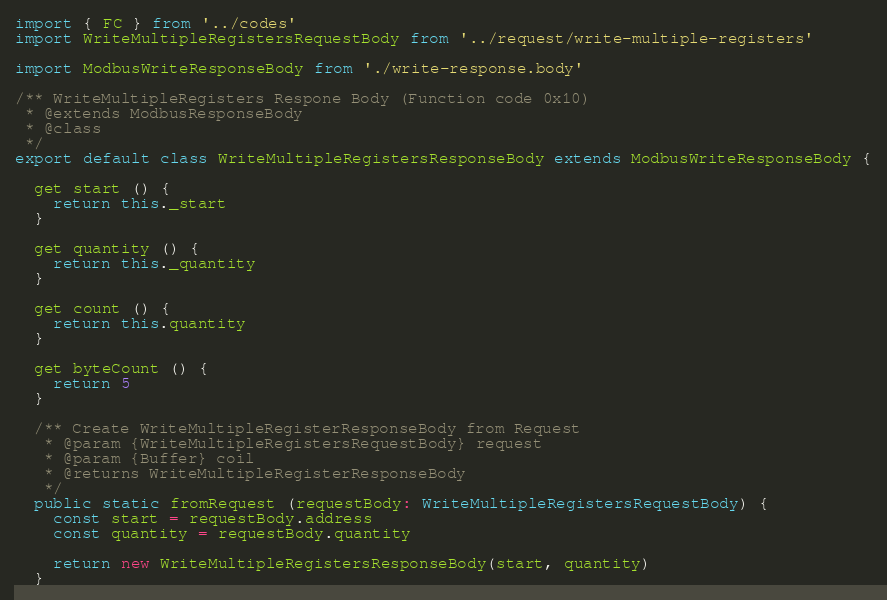<code> <loc_0><loc_0><loc_500><loc_500><_TypeScript_>import { FC } from '../codes'
import WriteMultipleRegistersRequestBody from '../request/write-multiple-registers'

import ModbusWriteResponseBody from './write-response.body'

/** WriteMultipleRegisters Respone Body (Function code 0x10)
 * @extends ModbusResponseBody
 * @class
 */
export default class WriteMultipleRegistersResponseBody extends ModbusWriteResponseBody {

  get start () {
    return this._start
  }

  get quantity () {
    return this._quantity
  }

  get count () {
    return this.quantity
  }

  get byteCount () {
    return 5
  }

  /** Create WriteMultipleRegisterResponseBody from Request
   * @param {WriteMultipleRegistersRequestBody} request
   * @param {Buffer} coil
   * @returns WriteMultipleRegisterResponseBody
   */
  public static fromRequest (requestBody: WriteMultipleRegistersRequestBody) {
    const start = requestBody.address
    const quantity = requestBody.quantity

    return new WriteMultipleRegistersResponseBody(start, quantity)
  }
</code> 